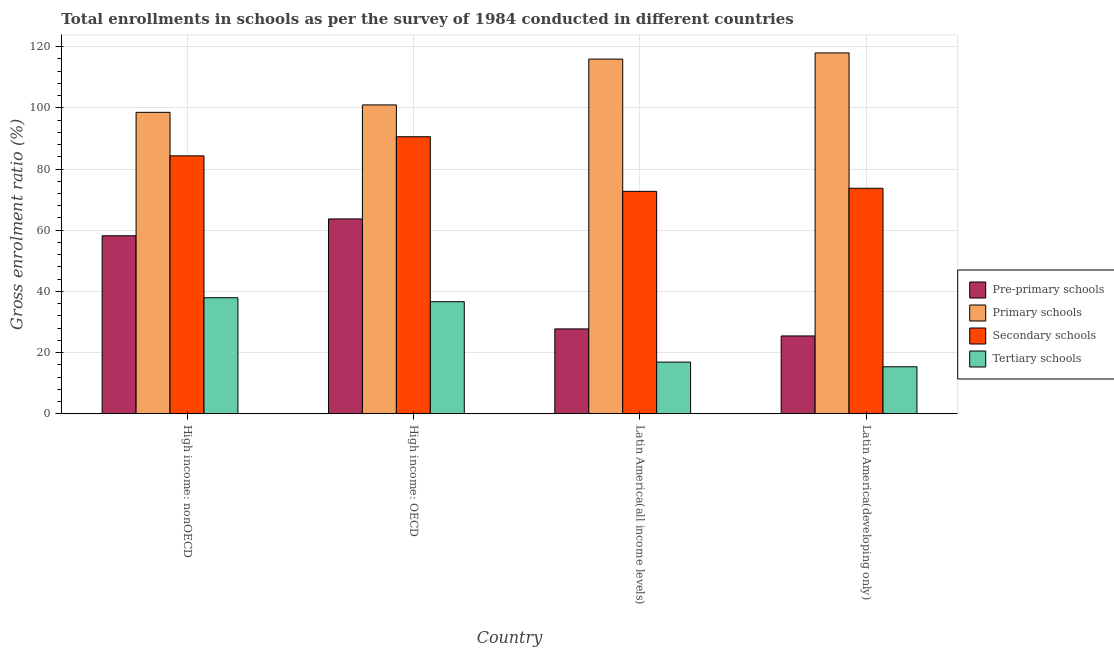How many groups of bars are there?
Ensure brevity in your answer.  4. Are the number of bars per tick equal to the number of legend labels?
Keep it short and to the point. Yes. Are the number of bars on each tick of the X-axis equal?
Offer a very short reply. Yes. What is the label of the 4th group of bars from the left?
Provide a short and direct response. Latin America(developing only). What is the gross enrolment ratio in primary schools in High income: OECD?
Ensure brevity in your answer.  100.95. Across all countries, what is the maximum gross enrolment ratio in pre-primary schools?
Ensure brevity in your answer.  63.68. Across all countries, what is the minimum gross enrolment ratio in primary schools?
Give a very brief answer. 98.52. In which country was the gross enrolment ratio in pre-primary schools maximum?
Give a very brief answer. High income: OECD. In which country was the gross enrolment ratio in primary schools minimum?
Your answer should be compact. High income: nonOECD. What is the total gross enrolment ratio in secondary schools in the graph?
Your response must be concise. 321.23. What is the difference between the gross enrolment ratio in tertiary schools in High income: OECD and that in High income: nonOECD?
Offer a terse response. -1.3. What is the difference between the gross enrolment ratio in pre-primary schools in High income: OECD and the gross enrolment ratio in tertiary schools in Latin America(developing only)?
Keep it short and to the point. 48.33. What is the average gross enrolment ratio in pre-primary schools per country?
Your answer should be very brief. 43.75. What is the difference between the gross enrolment ratio in pre-primary schools and gross enrolment ratio in tertiary schools in High income: nonOECD?
Ensure brevity in your answer.  20.25. What is the ratio of the gross enrolment ratio in pre-primary schools in High income: OECD to that in High income: nonOECD?
Give a very brief answer. 1.09. What is the difference between the highest and the second highest gross enrolment ratio in primary schools?
Provide a succinct answer. 2.02. What is the difference between the highest and the lowest gross enrolment ratio in pre-primary schools?
Your answer should be very brief. 38.25. In how many countries, is the gross enrolment ratio in tertiary schools greater than the average gross enrolment ratio in tertiary schools taken over all countries?
Offer a terse response. 2. Is the sum of the gross enrolment ratio in tertiary schools in High income: OECD and Latin America(all income levels) greater than the maximum gross enrolment ratio in secondary schools across all countries?
Provide a succinct answer. No. Is it the case that in every country, the sum of the gross enrolment ratio in primary schools and gross enrolment ratio in tertiary schools is greater than the sum of gross enrolment ratio in pre-primary schools and gross enrolment ratio in secondary schools?
Your answer should be very brief. No. What does the 2nd bar from the left in Latin America(all income levels) represents?
Keep it short and to the point. Primary schools. What does the 3rd bar from the right in High income: nonOECD represents?
Provide a succinct answer. Primary schools. How many bars are there?
Provide a succinct answer. 16. Are all the bars in the graph horizontal?
Offer a terse response. No. What is the difference between two consecutive major ticks on the Y-axis?
Offer a very short reply. 20. Does the graph contain grids?
Provide a succinct answer. Yes. How many legend labels are there?
Provide a short and direct response. 4. What is the title of the graph?
Your response must be concise. Total enrollments in schools as per the survey of 1984 conducted in different countries. What is the label or title of the X-axis?
Your response must be concise. Country. What is the Gross enrolment ratio (%) of Pre-primary schools in High income: nonOECD?
Your answer should be very brief. 58.17. What is the Gross enrolment ratio (%) of Primary schools in High income: nonOECD?
Provide a succinct answer. 98.52. What is the Gross enrolment ratio (%) of Secondary schools in High income: nonOECD?
Ensure brevity in your answer.  84.29. What is the Gross enrolment ratio (%) of Tertiary schools in High income: nonOECD?
Your answer should be compact. 37.92. What is the Gross enrolment ratio (%) in Pre-primary schools in High income: OECD?
Keep it short and to the point. 63.68. What is the Gross enrolment ratio (%) in Primary schools in High income: OECD?
Keep it short and to the point. 100.95. What is the Gross enrolment ratio (%) of Secondary schools in High income: OECD?
Provide a short and direct response. 90.54. What is the Gross enrolment ratio (%) of Tertiary schools in High income: OECD?
Provide a succinct answer. 36.62. What is the Gross enrolment ratio (%) of Pre-primary schools in Latin America(all income levels)?
Offer a very short reply. 27.73. What is the Gross enrolment ratio (%) of Primary schools in Latin America(all income levels)?
Keep it short and to the point. 115.92. What is the Gross enrolment ratio (%) of Secondary schools in Latin America(all income levels)?
Make the answer very short. 72.7. What is the Gross enrolment ratio (%) of Tertiary schools in Latin America(all income levels)?
Ensure brevity in your answer.  16.88. What is the Gross enrolment ratio (%) in Pre-primary schools in Latin America(developing only)?
Give a very brief answer. 25.43. What is the Gross enrolment ratio (%) of Primary schools in Latin America(developing only)?
Make the answer very short. 117.95. What is the Gross enrolment ratio (%) in Secondary schools in Latin America(developing only)?
Ensure brevity in your answer.  73.7. What is the Gross enrolment ratio (%) of Tertiary schools in Latin America(developing only)?
Ensure brevity in your answer.  15.35. Across all countries, what is the maximum Gross enrolment ratio (%) in Pre-primary schools?
Make the answer very short. 63.68. Across all countries, what is the maximum Gross enrolment ratio (%) in Primary schools?
Ensure brevity in your answer.  117.95. Across all countries, what is the maximum Gross enrolment ratio (%) of Secondary schools?
Offer a very short reply. 90.54. Across all countries, what is the maximum Gross enrolment ratio (%) in Tertiary schools?
Give a very brief answer. 37.92. Across all countries, what is the minimum Gross enrolment ratio (%) of Pre-primary schools?
Ensure brevity in your answer.  25.43. Across all countries, what is the minimum Gross enrolment ratio (%) of Primary schools?
Keep it short and to the point. 98.52. Across all countries, what is the minimum Gross enrolment ratio (%) in Secondary schools?
Offer a very short reply. 72.7. Across all countries, what is the minimum Gross enrolment ratio (%) in Tertiary schools?
Provide a succinct answer. 15.35. What is the total Gross enrolment ratio (%) in Pre-primary schools in the graph?
Your answer should be compact. 175.01. What is the total Gross enrolment ratio (%) of Primary schools in the graph?
Offer a very short reply. 433.34. What is the total Gross enrolment ratio (%) of Secondary schools in the graph?
Ensure brevity in your answer.  321.23. What is the total Gross enrolment ratio (%) of Tertiary schools in the graph?
Your response must be concise. 106.77. What is the difference between the Gross enrolment ratio (%) of Pre-primary schools in High income: nonOECD and that in High income: OECD?
Offer a very short reply. -5.51. What is the difference between the Gross enrolment ratio (%) in Primary schools in High income: nonOECD and that in High income: OECD?
Your answer should be very brief. -2.43. What is the difference between the Gross enrolment ratio (%) in Secondary schools in High income: nonOECD and that in High income: OECD?
Provide a succinct answer. -6.25. What is the difference between the Gross enrolment ratio (%) of Tertiary schools in High income: nonOECD and that in High income: OECD?
Your answer should be very brief. 1.3. What is the difference between the Gross enrolment ratio (%) of Pre-primary schools in High income: nonOECD and that in Latin America(all income levels)?
Offer a very short reply. 30.44. What is the difference between the Gross enrolment ratio (%) in Primary schools in High income: nonOECD and that in Latin America(all income levels)?
Keep it short and to the point. -17.4. What is the difference between the Gross enrolment ratio (%) in Secondary schools in High income: nonOECD and that in Latin America(all income levels)?
Your answer should be compact. 11.6. What is the difference between the Gross enrolment ratio (%) of Tertiary schools in High income: nonOECD and that in Latin America(all income levels)?
Your answer should be compact. 21.05. What is the difference between the Gross enrolment ratio (%) in Pre-primary schools in High income: nonOECD and that in Latin America(developing only)?
Ensure brevity in your answer.  32.74. What is the difference between the Gross enrolment ratio (%) of Primary schools in High income: nonOECD and that in Latin America(developing only)?
Offer a very short reply. -19.42. What is the difference between the Gross enrolment ratio (%) of Secondary schools in High income: nonOECD and that in Latin America(developing only)?
Give a very brief answer. 10.59. What is the difference between the Gross enrolment ratio (%) in Tertiary schools in High income: nonOECD and that in Latin America(developing only)?
Keep it short and to the point. 22.57. What is the difference between the Gross enrolment ratio (%) in Pre-primary schools in High income: OECD and that in Latin America(all income levels)?
Your answer should be very brief. 35.95. What is the difference between the Gross enrolment ratio (%) in Primary schools in High income: OECD and that in Latin America(all income levels)?
Your answer should be compact. -14.97. What is the difference between the Gross enrolment ratio (%) in Secondary schools in High income: OECD and that in Latin America(all income levels)?
Your answer should be compact. 17.85. What is the difference between the Gross enrolment ratio (%) in Tertiary schools in High income: OECD and that in Latin America(all income levels)?
Ensure brevity in your answer.  19.74. What is the difference between the Gross enrolment ratio (%) of Pre-primary schools in High income: OECD and that in Latin America(developing only)?
Your answer should be very brief. 38.25. What is the difference between the Gross enrolment ratio (%) in Primary schools in High income: OECD and that in Latin America(developing only)?
Your response must be concise. -16.99. What is the difference between the Gross enrolment ratio (%) in Secondary schools in High income: OECD and that in Latin America(developing only)?
Provide a succinct answer. 16.84. What is the difference between the Gross enrolment ratio (%) in Tertiary schools in High income: OECD and that in Latin America(developing only)?
Offer a very short reply. 21.27. What is the difference between the Gross enrolment ratio (%) of Pre-primary schools in Latin America(all income levels) and that in Latin America(developing only)?
Ensure brevity in your answer.  2.3. What is the difference between the Gross enrolment ratio (%) of Primary schools in Latin America(all income levels) and that in Latin America(developing only)?
Offer a terse response. -2.02. What is the difference between the Gross enrolment ratio (%) in Secondary schools in Latin America(all income levels) and that in Latin America(developing only)?
Offer a terse response. -1. What is the difference between the Gross enrolment ratio (%) in Tertiary schools in Latin America(all income levels) and that in Latin America(developing only)?
Keep it short and to the point. 1.53. What is the difference between the Gross enrolment ratio (%) in Pre-primary schools in High income: nonOECD and the Gross enrolment ratio (%) in Primary schools in High income: OECD?
Offer a very short reply. -42.78. What is the difference between the Gross enrolment ratio (%) of Pre-primary schools in High income: nonOECD and the Gross enrolment ratio (%) of Secondary schools in High income: OECD?
Your response must be concise. -32.37. What is the difference between the Gross enrolment ratio (%) in Pre-primary schools in High income: nonOECD and the Gross enrolment ratio (%) in Tertiary schools in High income: OECD?
Your answer should be compact. 21.55. What is the difference between the Gross enrolment ratio (%) of Primary schools in High income: nonOECD and the Gross enrolment ratio (%) of Secondary schools in High income: OECD?
Offer a terse response. 7.98. What is the difference between the Gross enrolment ratio (%) in Primary schools in High income: nonOECD and the Gross enrolment ratio (%) in Tertiary schools in High income: OECD?
Ensure brevity in your answer.  61.9. What is the difference between the Gross enrolment ratio (%) in Secondary schools in High income: nonOECD and the Gross enrolment ratio (%) in Tertiary schools in High income: OECD?
Ensure brevity in your answer.  47.67. What is the difference between the Gross enrolment ratio (%) in Pre-primary schools in High income: nonOECD and the Gross enrolment ratio (%) in Primary schools in Latin America(all income levels)?
Your answer should be compact. -57.75. What is the difference between the Gross enrolment ratio (%) of Pre-primary schools in High income: nonOECD and the Gross enrolment ratio (%) of Secondary schools in Latin America(all income levels)?
Provide a short and direct response. -14.52. What is the difference between the Gross enrolment ratio (%) in Pre-primary schools in High income: nonOECD and the Gross enrolment ratio (%) in Tertiary schools in Latin America(all income levels)?
Offer a very short reply. 41.29. What is the difference between the Gross enrolment ratio (%) of Primary schools in High income: nonOECD and the Gross enrolment ratio (%) of Secondary schools in Latin America(all income levels)?
Your answer should be very brief. 25.83. What is the difference between the Gross enrolment ratio (%) of Primary schools in High income: nonOECD and the Gross enrolment ratio (%) of Tertiary schools in Latin America(all income levels)?
Provide a succinct answer. 81.65. What is the difference between the Gross enrolment ratio (%) of Secondary schools in High income: nonOECD and the Gross enrolment ratio (%) of Tertiary schools in Latin America(all income levels)?
Give a very brief answer. 67.42. What is the difference between the Gross enrolment ratio (%) in Pre-primary schools in High income: nonOECD and the Gross enrolment ratio (%) in Primary schools in Latin America(developing only)?
Your answer should be compact. -59.77. What is the difference between the Gross enrolment ratio (%) of Pre-primary schools in High income: nonOECD and the Gross enrolment ratio (%) of Secondary schools in Latin America(developing only)?
Ensure brevity in your answer.  -15.53. What is the difference between the Gross enrolment ratio (%) of Pre-primary schools in High income: nonOECD and the Gross enrolment ratio (%) of Tertiary schools in Latin America(developing only)?
Make the answer very short. 42.82. What is the difference between the Gross enrolment ratio (%) in Primary schools in High income: nonOECD and the Gross enrolment ratio (%) in Secondary schools in Latin America(developing only)?
Provide a succinct answer. 24.82. What is the difference between the Gross enrolment ratio (%) in Primary schools in High income: nonOECD and the Gross enrolment ratio (%) in Tertiary schools in Latin America(developing only)?
Your response must be concise. 83.17. What is the difference between the Gross enrolment ratio (%) of Secondary schools in High income: nonOECD and the Gross enrolment ratio (%) of Tertiary schools in Latin America(developing only)?
Provide a succinct answer. 68.94. What is the difference between the Gross enrolment ratio (%) in Pre-primary schools in High income: OECD and the Gross enrolment ratio (%) in Primary schools in Latin America(all income levels)?
Offer a very short reply. -52.24. What is the difference between the Gross enrolment ratio (%) in Pre-primary schools in High income: OECD and the Gross enrolment ratio (%) in Secondary schools in Latin America(all income levels)?
Ensure brevity in your answer.  -9.01. What is the difference between the Gross enrolment ratio (%) in Pre-primary schools in High income: OECD and the Gross enrolment ratio (%) in Tertiary schools in Latin America(all income levels)?
Your response must be concise. 46.8. What is the difference between the Gross enrolment ratio (%) of Primary schools in High income: OECD and the Gross enrolment ratio (%) of Secondary schools in Latin America(all income levels)?
Offer a terse response. 28.25. What is the difference between the Gross enrolment ratio (%) in Primary schools in High income: OECD and the Gross enrolment ratio (%) in Tertiary schools in Latin America(all income levels)?
Make the answer very short. 84.07. What is the difference between the Gross enrolment ratio (%) of Secondary schools in High income: OECD and the Gross enrolment ratio (%) of Tertiary schools in Latin America(all income levels)?
Provide a succinct answer. 73.67. What is the difference between the Gross enrolment ratio (%) of Pre-primary schools in High income: OECD and the Gross enrolment ratio (%) of Primary schools in Latin America(developing only)?
Keep it short and to the point. -54.26. What is the difference between the Gross enrolment ratio (%) of Pre-primary schools in High income: OECD and the Gross enrolment ratio (%) of Secondary schools in Latin America(developing only)?
Your response must be concise. -10.02. What is the difference between the Gross enrolment ratio (%) in Pre-primary schools in High income: OECD and the Gross enrolment ratio (%) in Tertiary schools in Latin America(developing only)?
Give a very brief answer. 48.33. What is the difference between the Gross enrolment ratio (%) of Primary schools in High income: OECD and the Gross enrolment ratio (%) of Secondary schools in Latin America(developing only)?
Provide a short and direct response. 27.25. What is the difference between the Gross enrolment ratio (%) of Primary schools in High income: OECD and the Gross enrolment ratio (%) of Tertiary schools in Latin America(developing only)?
Offer a very short reply. 85.6. What is the difference between the Gross enrolment ratio (%) in Secondary schools in High income: OECD and the Gross enrolment ratio (%) in Tertiary schools in Latin America(developing only)?
Your response must be concise. 75.19. What is the difference between the Gross enrolment ratio (%) of Pre-primary schools in Latin America(all income levels) and the Gross enrolment ratio (%) of Primary schools in Latin America(developing only)?
Your answer should be compact. -90.22. What is the difference between the Gross enrolment ratio (%) in Pre-primary schools in Latin America(all income levels) and the Gross enrolment ratio (%) in Secondary schools in Latin America(developing only)?
Your response must be concise. -45.97. What is the difference between the Gross enrolment ratio (%) in Pre-primary schools in Latin America(all income levels) and the Gross enrolment ratio (%) in Tertiary schools in Latin America(developing only)?
Make the answer very short. 12.38. What is the difference between the Gross enrolment ratio (%) in Primary schools in Latin America(all income levels) and the Gross enrolment ratio (%) in Secondary schools in Latin America(developing only)?
Make the answer very short. 42.22. What is the difference between the Gross enrolment ratio (%) in Primary schools in Latin America(all income levels) and the Gross enrolment ratio (%) in Tertiary schools in Latin America(developing only)?
Offer a very short reply. 100.57. What is the difference between the Gross enrolment ratio (%) in Secondary schools in Latin America(all income levels) and the Gross enrolment ratio (%) in Tertiary schools in Latin America(developing only)?
Ensure brevity in your answer.  57.34. What is the average Gross enrolment ratio (%) in Pre-primary schools per country?
Provide a short and direct response. 43.75. What is the average Gross enrolment ratio (%) in Primary schools per country?
Provide a short and direct response. 108.34. What is the average Gross enrolment ratio (%) of Secondary schools per country?
Keep it short and to the point. 80.31. What is the average Gross enrolment ratio (%) of Tertiary schools per country?
Provide a short and direct response. 26.69. What is the difference between the Gross enrolment ratio (%) of Pre-primary schools and Gross enrolment ratio (%) of Primary schools in High income: nonOECD?
Your response must be concise. -40.35. What is the difference between the Gross enrolment ratio (%) of Pre-primary schools and Gross enrolment ratio (%) of Secondary schools in High income: nonOECD?
Provide a short and direct response. -26.12. What is the difference between the Gross enrolment ratio (%) in Pre-primary schools and Gross enrolment ratio (%) in Tertiary schools in High income: nonOECD?
Give a very brief answer. 20.25. What is the difference between the Gross enrolment ratio (%) of Primary schools and Gross enrolment ratio (%) of Secondary schools in High income: nonOECD?
Your answer should be very brief. 14.23. What is the difference between the Gross enrolment ratio (%) in Primary schools and Gross enrolment ratio (%) in Tertiary schools in High income: nonOECD?
Ensure brevity in your answer.  60.6. What is the difference between the Gross enrolment ratio (%) in Secondary schools and Gross enrolment ratio (%) in Tertiary schools in High income: nonOECD?
Offer a very short reply. 46.37. What is the difference between the Gross enrolment ratio (%) in Pre-primary schools and Gross enrolment ratio (%) in Primary schools in High income: OECD?
Ensure brevity in your answer.  -37.27. What is the difference between the Gross enrolment ratio (%) of Pre-primary schools and Gross enrolment ratio (%) of Secondary schools in High income: OECD?
Your answer should be very brief. -26.86. What is the difference between the Gross enrolment ratio (%) of Pre-primary schools and Gross enrolment ratio (%) of Tertiary schools in High income: OECD?
Give a very brief answer. 27.06. What is the difference between the Gross enrolment ratio (%) in Primary schools and Gross enrolment ratio (%) in Secondary schools in High income: OECD?
Give a very brief answer. 10.41. What is the difference between the Gross enrolment ratio (%) in Primary schools and Gross enrolment ratio (%) in Tertiary schools in High income: OECD?
Keep it short and to the point. 64.33. What is the difference between the Gross enrolment ratio (%) in Secondary schools and Gross enrolment ratio (%) in Tertiary schools in High income: OECD?
Offer a very short reply. 53.92. What is the difference between the Gross enrolment ratio (%) in Pre-primary schools and Gross enrolment ratio (%) in Primary schools in Latin America(all income levels)?
Your response must be concise. -88.19. What is the difference between the Gross enrolment ratio (%) in Pre-primary schools and Gross enrolment ratio (%) in Secondary schools in Latin America(all income levels)?
Give a very brief answer. -44.97. What is the difference between the Gross enrolment ratio (%) of Pre-primary schools and Gross enrolment ratio (%) of Tertiary schools in Latin America(all income levels)?
Give a very brief answer. 10.85. What is the difference between the Gross enrolment ratio (%) in Primary schools and Gross enrolment ratio (%) in Secondary schools in Latin America(all income levels)?
Give a very brief answer. 43.23. What is the difference between the Gross enrolment ratio (%) of Primary schools and Gross enrolment ratio (%) of Tertiary schools in Latin America(all income levels)?
Provide a succinct answer. 99.04. What is the difference between the Gross enrolment ratio (%) of Secondary schools and Gross enrolment ratio (%) of Tertiary schools in Latin America(all income levels)?
Offer a terse response. 55.82. What is the difference between the Gross enrolment ratio (%) of Pre-primary schools and Gross enrolment ratio (%) of Primary schools in Latin America(developing only)?
Provide a short and direct response. -92.52. What is the difference between the Gross enrolment ratio (%) in Pre-primary schools and Gross enrolment ratio (%) in Secondary schools in Latin America(developing only)?
Ensure brevity in your answer.  -48.27. What is the difference between the Gross enrolment ratio (%) of Pre-primary schools and Gross enrolment ratio (%) of Tertiary schools in Latin America(developing only)?
Make the answer very short. 10.08. What is the difference between the Gross enrolment ratio (%) of Primary schools and Gross enrolment ratio (%) of Secondary schools in Latin America(developing only)?
Give a very brief answer. 44.24. What is the difference between the Gross enrolment ratio (%) of Primary schools and Gross enrolment ratio (%) of Tertiary schools in Latin America(developing only)?
Offer a terse response. 102.59. What is the difference between the Gross enrolment ratio (%) in Secondary schools and Gross enrolment ratio (%) in Tertiary schools in Latin America(developing only)?
Keep it short and to the point. 58.35. What is the ratio of the Gross enrolment ratio (%) in Pre-primary schools in High income: nonOECD to that in High income: OECD?
Provide a short and direct response. 0.91. What is the ratio of the Gross enrolment ratio (%) of Tertiary schools in High income: nonOECD to that in High income: OECD?
Provide a short and direct response. 1.04. What is the ratio of the Gross enrolment ratio (%) in Pre-primary schools in High income: nonOECD to that in Latin America(all income levels)?
Your answer should be compact. 2.1. What is the ratio of the Gross enrolment ratio (%) of Primary schools in High income: nonOECD to that in Latin America(all income levels)?
Provide a short and direct response. 0.85. What is the ratio of the Gross enrolment ratio (%) in Secondary schools in High income: nonOECD to that in Latin America(all income levels)?
Your answer should be very brief. 1.16. What is the ratio of the Gross enrolment ratio (%) in Tertiary schools in High income: nonOECD to that in Latin America(all income levels)?
Make the answer very short. 2.25. What is the ratio of the Gross enrolment ratio (%) of Pre-primary schools in High income: nonOECD to that in Latin America(developing only)?
Provide a succinct answer. 2.29. What is the ratio of the Gross enrolment ratio (%) in Primary schools in High income: nonOECD to that in Latin America(developing only)?
Your answer should be compact. 0.84. What is the ratio of the Gross enrolment ratio (%) in Secondary schools in High income: nonOECD to that in Latin America(developing only)?
Keep it short and to the point. 1.14. What is the ratio of the Gross enrolment ratio (%) of Tertiary schools in High income: nonOECD to that in Latin America(developing only)?
Offer a very short reply. 2.47. What is the ratio of the Gross enrolment ratio (%) of Pre-primary schools in High income: OECD to that in Latin America(all income levels)?
Give a very brief answer. 2.3. What is the ratio of the Gross enrolment ratio (%) of Primary schools in High income: OECD to that in Latin America(all income levels)?
Offer a very short reply. 0.87. What is the ratio of the Gross enrolment ratio (%) of Secondary schools in High income: OECD to that in Latin America(all income levels)?
Keep it short and to the point. 1.25. What is the ratio of the Gross enrolment ratio (%) of Tertiary schools in High income: OECD to that in Latin America(all income levels)?
Your answer should be compact. 2.17. What is the ratio of the Gross enrolment ratio (%) in Pre-primary schools in High income: OECD to that in Latin America(developing only)?
Your answer should be very brief. 2.5. What is the ratio of the Gross enrolment ratio (%) in Primary schools in High income: OECD to that in Latin America(developing only)?
Make the answer very short. 0.86. What is the ratio of the Gross enrolment ratio (%) in Secondary schools in High income: OECD to that in Latin America(developing only)?
Your answer should be very brief. 1.23. What is the ratio of the Gross enrolment ratio (%) in Tertiary schools in High income: OECD to that in Latin America(developing only)?
Provide a short and direct response. 2.39. What is the ratio of the Gross enrolment ratio (%) of Pre-primary schools in Latin America(all income levels) to that in Latin America(developing only)?
Your answer should be compact. 1.09. What is the ratio of the Gross enrolment ratio (%) of Primary schools in Latin America(all income levels) to that in Latin America(developing only)?
Provide a succinct answer. 0.98. What is the ratio of the Gross enrolment ratio (%) in Secondary schools in Latin America(all income levels) to that in Latin America(developing only)?
Make the answer very short. 0.99. What is the ratio of the Gross enrolment ratio (%) in Tertiary schools in Latin America(all income levels) to that in Latin America(developing only)?
Your response must be concise. 1.1. What is the difference between the highest and the second highest Gross enrolment ratio (%) in Pre-primary schools?
Your response must be concise. 5.51. What is the difference between the highest and the second highest Gross enrolment ratio (%) of Primary schools?
Make the answer very short. 2.02. What is the difference between the highest and the second highest Gross enrolment ratio (%) in Secondary schools?
Give a very brief answer. 6.25. What is the difference between the highest and the second highest Gross enrolment ratio (%) of Tertiary schools?
Give a very brief answer. 1.3. What is the difference between the highest and the lowest Gross enrolment ratio (%) of Pre-primary schools?
Ensure brevity in your answer.  38.25. What is the difference between the highest and the lowest Gross enrolment ratio (%) of Primary schools?
Make the answer very short. 19.42. What is the difference between the highest and the lowest Gross enrolment ratio (%) in Secondary schools?
Provide a short and direct response. 17.85. What is the difference between the highest and the lowest Gross enrolment ratio (%) of Tertiary schools?
Provide a succinct answer. 22.57. 